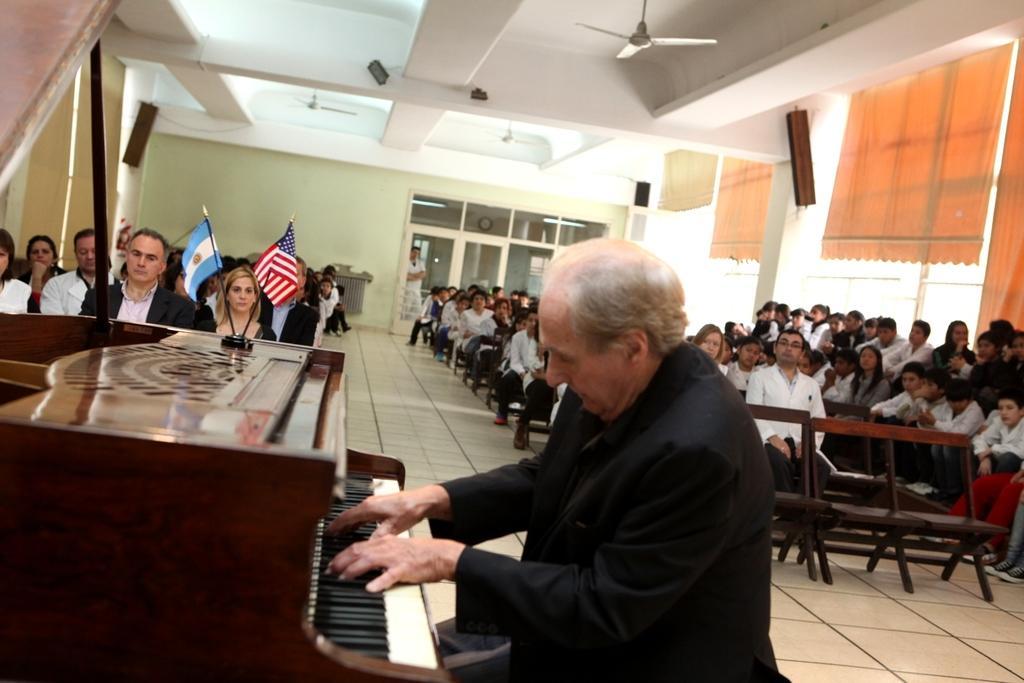In one or two sentences, can you explain what this image depicts? In this image i can see a group of people are sitting on a chair and the person in the front is playing a piano. 